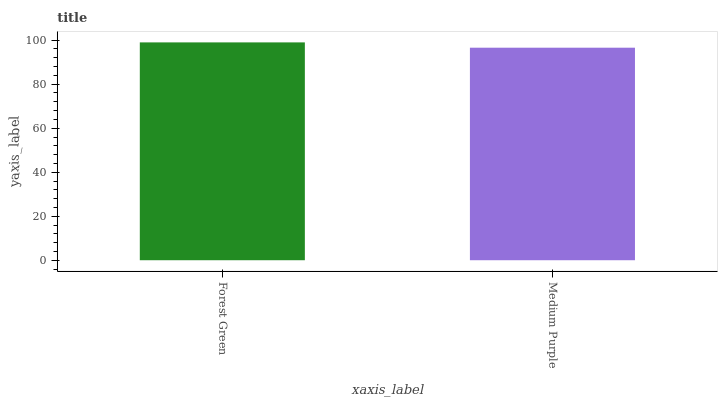Is Medium Purple the minimum?
Answer yes or no. Yes. Is Forest Green the maximum?
Answer yes or no. Yes. Is Medium Purple the maximum?
Answer yes or no. No. Is Forest Green greater than Medium Purple?
Answer yes or no. Yes. Is Medium Purple less than Forest Green?
Answer yes or no. Yes. Is Medium Purple greater than Forest Green?
Answer yes or no. No. Is Forest Green less than Medium Purple?
Answer yes or no. No. Is Forest Green the high median?
Answer yes or no. Yes. Is Medium Purple the low median?
Answer yes or no. Yes. Is Medium Purple the high median?
Answer yes or no. No. Is Forest Green the low median?
Answer yes or no. No. 